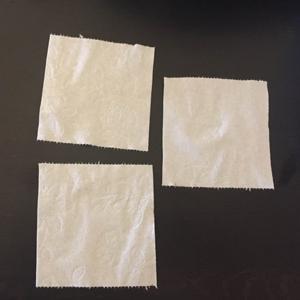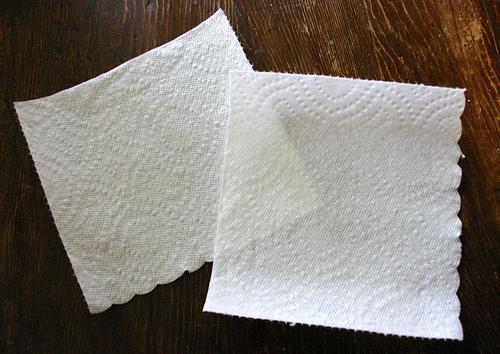The first image is the image on the left, the second image is the image on the right. For the images displayed, is the sentence "An image shows overlapping square white paper towels, each with the same embossed pattern." factually correct? Answer yes or no. Yes. The first image is the image on the left, the second image is the image on the right. Given the left and right images, does the statement "There are exactly five visible paper towels." hold true? Answer yes or no. Yes. 